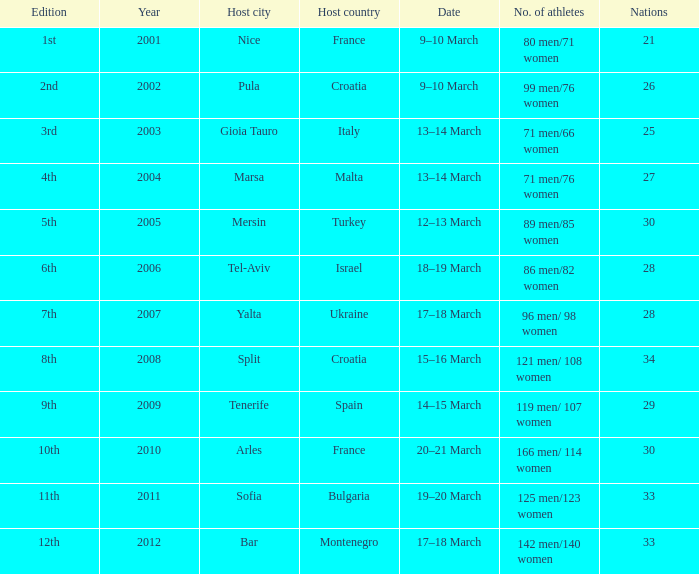In the host country of croatia, which city hosted the 8th edition? Split. 